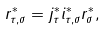<formula> <loc_0><loc_0><loc_500><loc_500>r _ { \tau , \sigma } ^ { * } = j _ { \tau } ^ { * } i _ { \tau , \sigma } ^ { * } r _ { \sigma } ^ { * } ,</formula> 